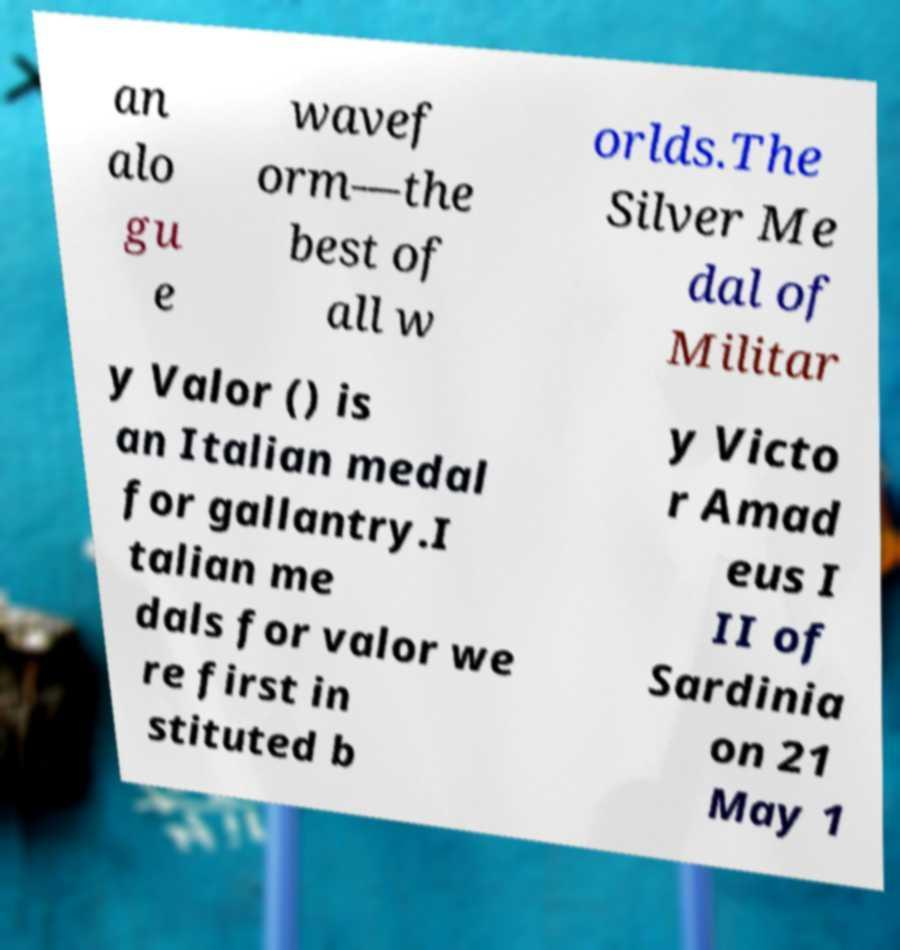Please identify and transcribe the text found in this image. an alo gu e wavef orm—the best of all w orlds.The Silver Me dal of Militar y Valor () is an Italian medal for gallantry.I talian me dals for valor we re first in stituted b y Victo r Amad eus I II of Sardinia on 21 May 1 